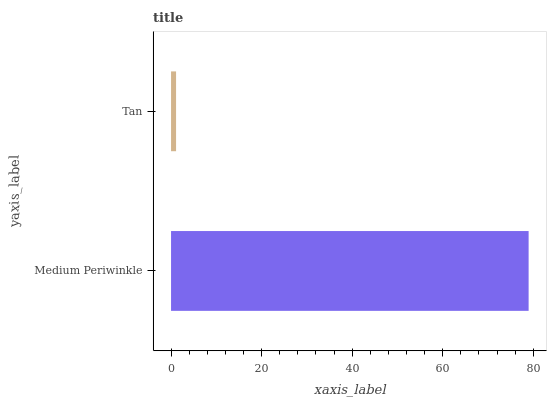Is Tan the minimum?
Answer yes or no. Yes. Is Medium Periwinkle the maximum?
Answer yes or no. Yes. Is Tan the maximum?
Answer yes or no. No. Is Medium Periwinkle greater than Tan?
Answer yes or no. Yes. Is Tan less than Medium Periwinkle?
Answer yes or no. Yes. Is Tan greater than Medium Periwinkle?
Answer yes or no. No. Is Medium Periwinkle less than Tan?
Answer yes or no. No. Is Medium Periwinkle the high median?
Answer yes or no. Yes. Is Tan the low median?
Answer yes or no. Yes. Is Tan the high median?
Answer yes or no. No. Is Medium Periwinkle the low median?
Answer yes or no. No. 